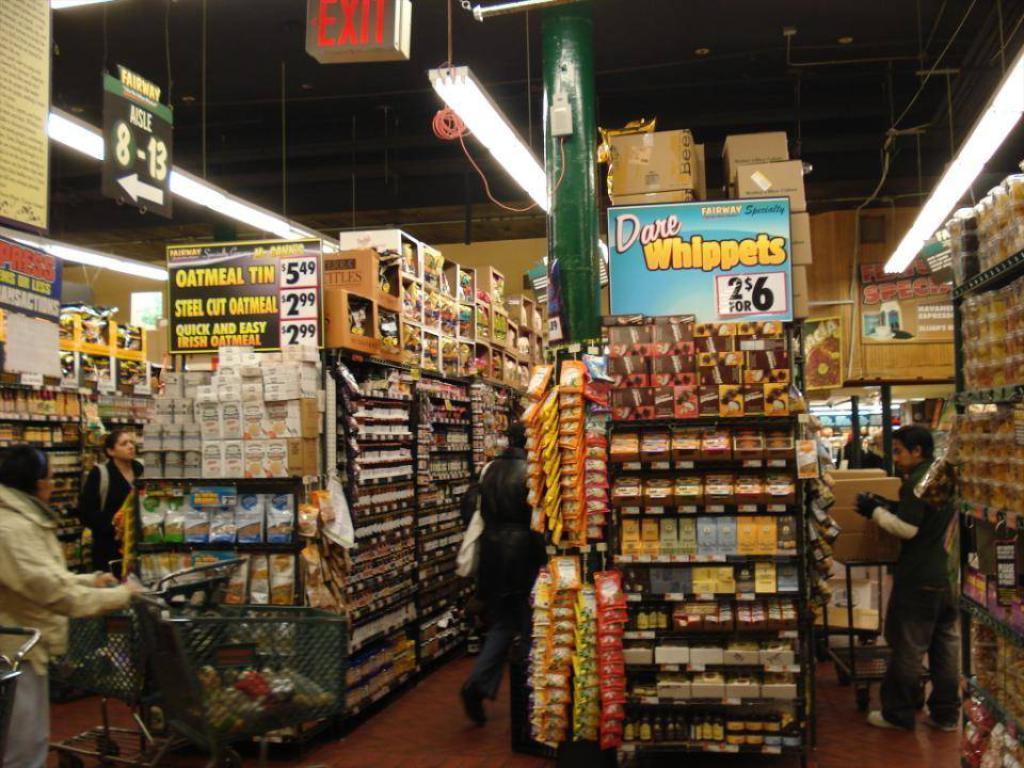What is being sold 2 for $6?
Make the answer very short. Dare whippets. What is in the tin that costs $5.49?
Keep it short and to the point. Oatmeal. 